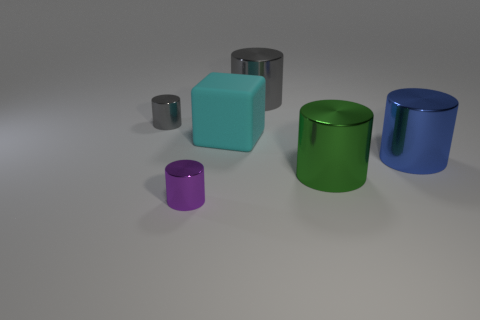What are the different colors of cylinders present in the image? In the image, we observe cylinders in several distinct colors, namely purple, green, blue, and gray. Each color adds to the visual diversity and creates an interesting composition of colorful geometric shapes. 